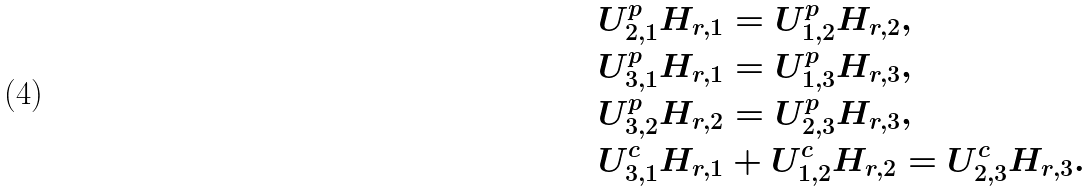<formula> <loc_0><loc_0><loc_500><loc_500>& { U } _ { 2 , 1 } ^ { p } { H } _ { r , 1 } = { U } _ { 1 , 2 } ^ { p } { H } _ { r , 2 } , \\ & { U } _ { 3 , 1 } ^ { p } { H } _ { r , 1 } = { U } _ { 1 , 3 } ^ { p } { H } _ { r , 3 } , \\ & { U } _ { 3 , 2 } ^ { p } { H } _ { r , 2 } = { U } _ { 2 , 3 } ^ { p } { H } _ { r , 3 } , \\ & { U } _ { 3 , 1 } ^ { c } { H } _ { r , 1 } + { U } _ { 1 , 2 } ^ { c } { H } _ { r , 2 } = { U } _ { 2 , 3 } ^ { c } { H } _ { r , 3 } .</formula> 